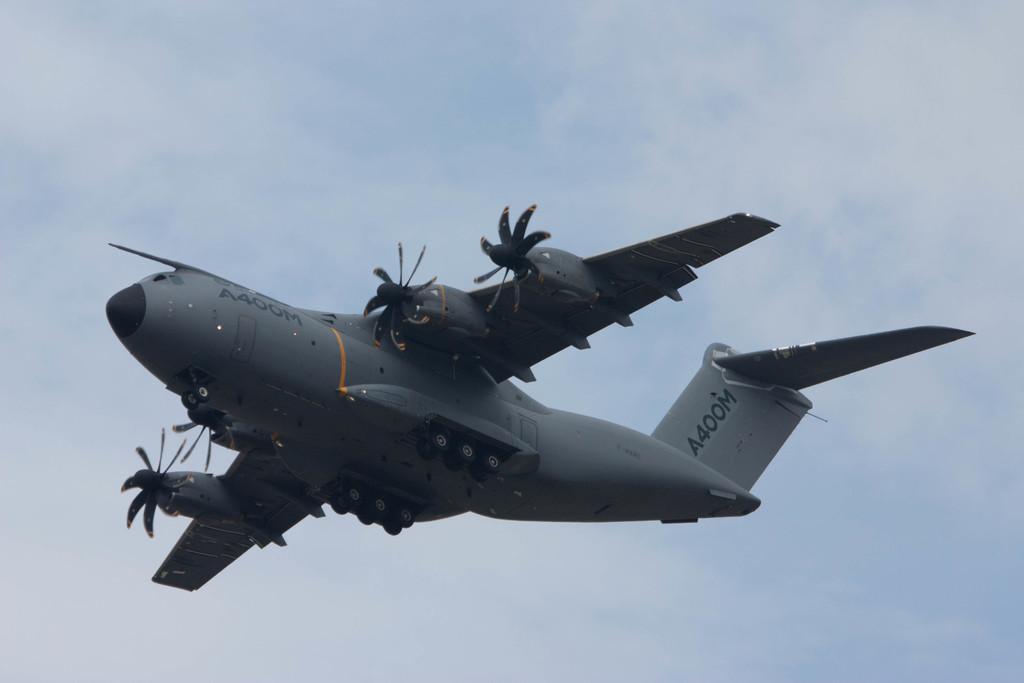Please provide a concise description of this image. In this image we can see a plane is flying in the air. In the background we can see clouds in the sky. 